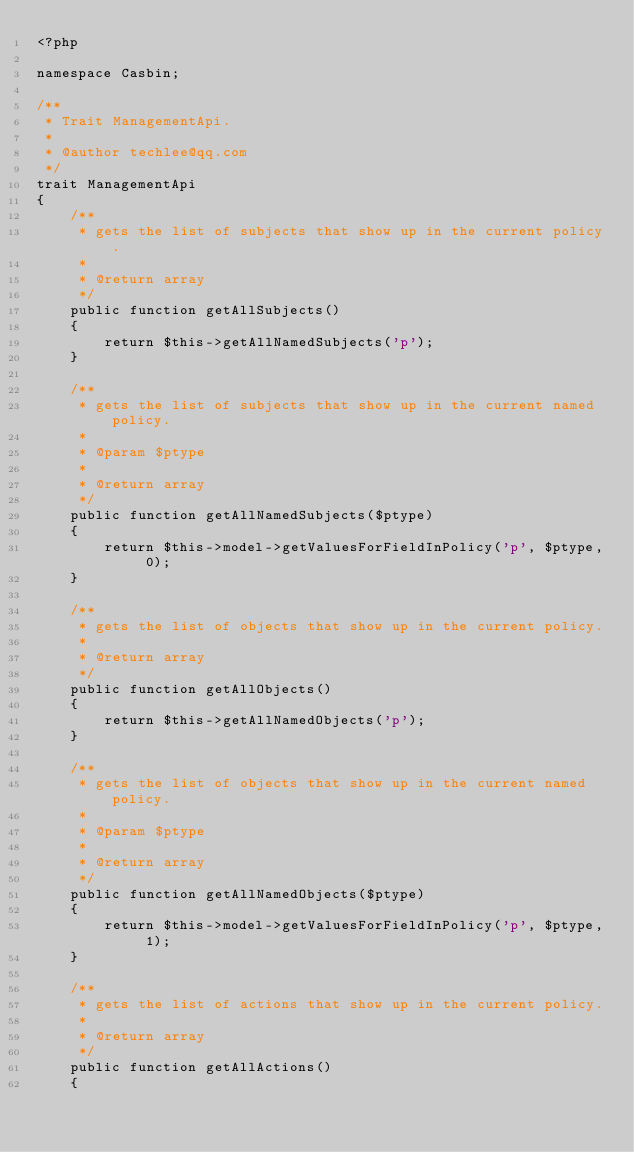<code> <loc_0><loc_0><loc_500><loc_500><_PHP_><?php

namespace Casbin;

/**
 * Trait ManagementApi.
 *
 * @author techlee@qq.com
 */
trait ManagementApi
{
    /**
     * gets the list of subjects that show up in the current policy.
     *
     * @return array
     */
    public function getAllSubjects()
    {
        return $this->getAllNamedSubjects('p');
    }

    /**
     * gets the list of subjects that show up in the current named policy.
     *
     * @param $ptype
     *
     * @return array
     */
    public function getAllNamedSubjects($ptype)
    {
        return $this->model->getValuesForFieldInPolicy('p', $ptype, 0);
    }

    /**
     * gets the list of objects that show up in the current policy.
     *
     * @return array
     */
    public function getAllObjects()
    {
        return $this->getAllNamedObjects('p');
    }

    /**
     * gets the list of objects that show up in the current named policy.
     *
     * @param $ptype
     *
     * @return array
     */
    public function getAllNamedObjects($ptype)
    {
        return $this->model->getValuesForFieldInPolicy('p', $ptype, 1);
    }

    /**
     * gets the list of actions that show up in the current policy.
     *
     * @return array
     */
    public function getAllActions()
    {</code> 